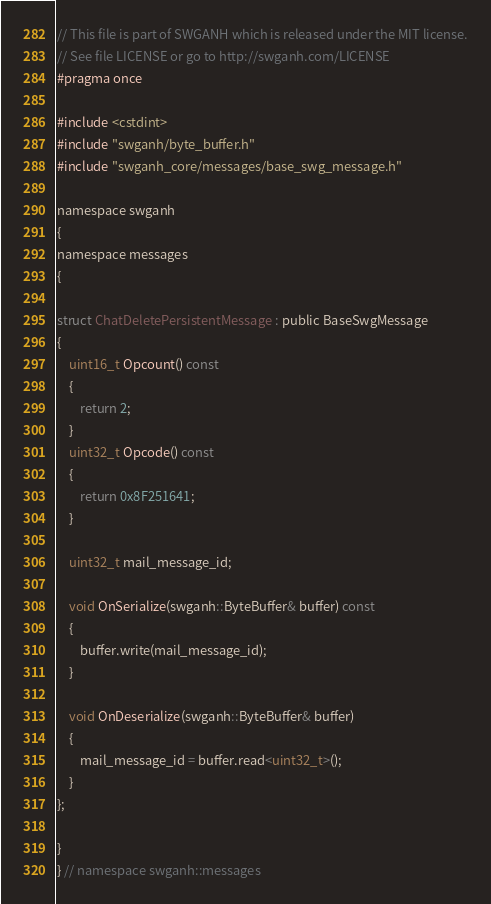<code> <loc_0><loc_0><loc_500><loc_500><_C_>// This file is part of SWGANH which is released under the MIT license.
// See file LICENSE or go to http://swganh.com/LICENSE
#pragma once

#include <cstdint>
#include "swganh/byte_buffer.h"
#include "swganh_core/messages/base_swg_message.h"

namespace swganh
{
namespace messages
{

struct ChatDeletePersistentMessage : public BaseSwgMessage
{
    uint16_t Opcount() const
    {
        return 2;
    }
    uint32_t Opcode() const
    {
        return 0x8F251641;
    }

    uint32_t mail_message_id;

    void OnSerialize(swganh::ByteBuffer& buffer) const
    {
        buffer.write(mail_message_id);
    }

    void OnDeserialize(swganh::ByteBuffer& buffer)
    {
        mail_message_id = buffer.read<uint32_t>();
    }
};

}
} // namespace swganh::messages
</code> 